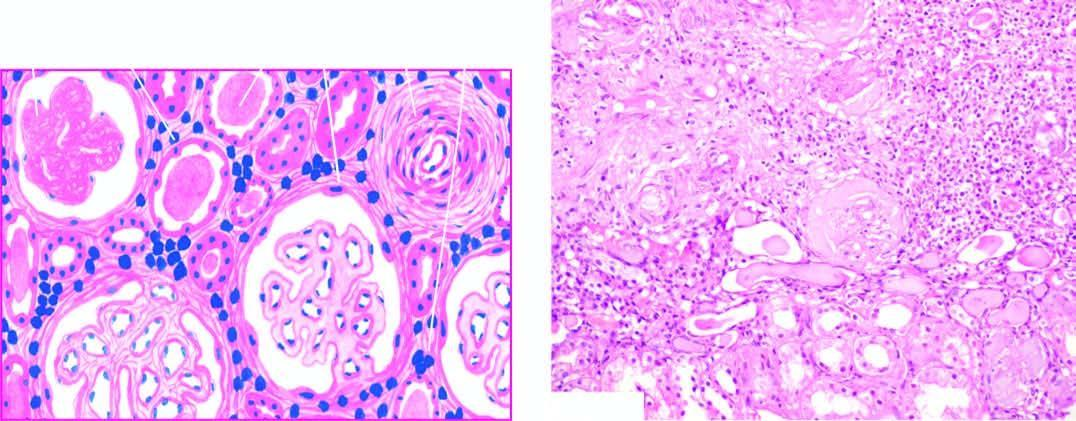what does the scarred area show?
Answer the question using a single word or phrase. Atrophy of some tubules and dilatation of others which contain colloid casts thyroidisation 